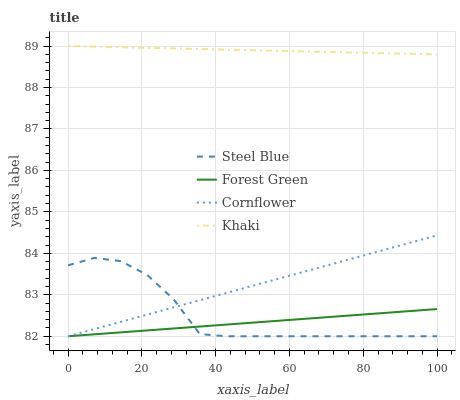Does Forest Green have the minimum area under the curve?
Answer yes or no. Yes. Does Khaki have the maximum area under the curve?
Answer yes or no. Yes. Does Khaki have the minimum area under the curve?
Answer yes or no. No. Does Forest Green have the maximum area under the curve?
Answer yes or no. No. Is Forest Green the smoothest?
Answer yes or no. Yes. Is Steel Blue the roughest?
Answer yes or no. Yes. Is Khaki the smoothest?
Answer yes or no. No. Is Khaki the roughest?
Answer yes or no. No. Does Cornflower have the lowest value?
Answer yes or no. Yes. Does Khaki have the lowest value?
Answer yes or no. No. Does Khaki have the highest value?
Answer yes or no. Yes. Does Forest Green have the highest value?
Answer yes or no. No. Is Cornflower less than Khaki?
Answer yes or no. Yes. Is Khaki greater than Forest Green?
Answer yes or no. Yes. Does Forest Green intersect Cornflower?
Answer yes or no. Yes. Is Forest Green less than Cornflower?
Answer yes or no. No. Is Forest Green greater than Cornflower?
Answer yes or no. No. Does Cornflower intersect Khaki?
Answer yes or no. No. 